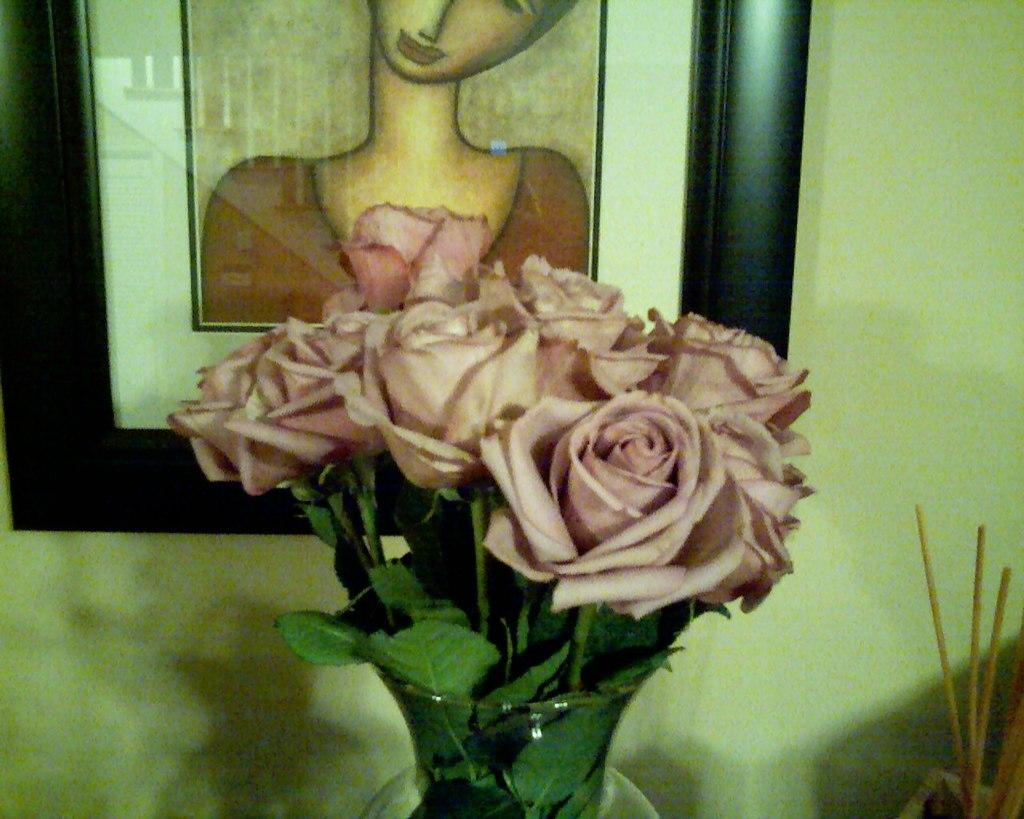What object can be seen in the image that might hold flowers? There is a flower vase in the image. What can be seen on the wall in the background of the image? There is a photo frame on the wall in the background of the image. How many ducks are swimming in the flower vase in the image? There are no ducks present in the flower vase or the image. What team is associated with the photo frame in the image? There is no information about a team or any association with a photo frame in the image. 